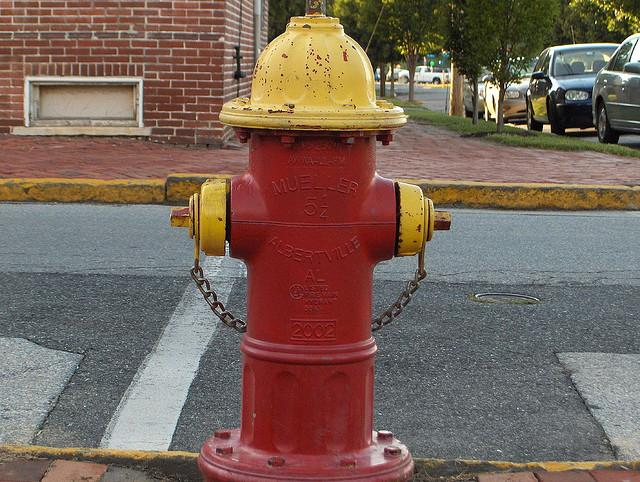The red color of fire hydrant represents what? Please explain your reasoning. water force. The red color is a water force. 